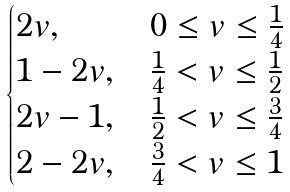<formula> <loc_0><loc_0><loc_500><loc_500>\begin{cases} 2 v , & 0 \leq v \leq \frac { 1 } { 4 } \\ 1 - 2 v , & \frac { 1 } { 4 } < v \leq \frac { 1 } { 2 } \\ 2 v - 1 , & \frac { 1 } { 2 } < v \leq \frac { 3 } { 4 } \\ 2 - 2 v , & \frac { 3 } { 4 } < v \leq 1 \end{cases}</formula> 